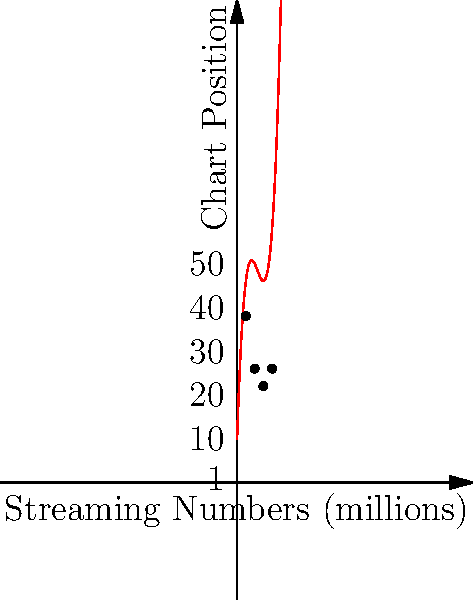As a music critic analyzing Taylor Swift's album performance, you've plotted the relationship between streaming numbers and chart positions for her recent albums using polynomial regression. The graph shows the trend line and actual data points. Based on the polynomial function $f(x) = 0.5x^3 - 7x^2 + 30x + 10$, where $x$ represents streaming numbers in millions and $f(x)$ represents chart position, at approximately how many million streams does the album reach its peak (lowest) chart position? To find the streaming number where the album reaches its peak (lowest) chart position, we need to follow these steps:

1) The peak (lowest) chart position occurs at the minimum point of the function.

2) To find the minimum point, we need to find where the derivative of the function equals zero:
   $f'(x) = 1.5x^2 - 14x + 30$

3) Set $f'(x) = 0$:
   $1.5x^2 - 14x + 30 = 0$

4) This is a quadratic equation. We can solve it using the quadratic formula:
   $x = \frac{-b \pm \sqrt{b^2 - 4ac}}{2a}$

   Where $a = 1.5$, $b = -14$, and $c = 30$

5) Plugging in these values:
   $x = \frac{14 \pm \sqrt{196 - 180}}{3} = \frac{14 \pm 4}{3}$

6) This gives us two solutions:
   $x_1 = \frac{14 + 4}{3} = 6$ and $x_2 = \frac{14 - 4}{3} = \frac{10}{3}$

7) The second solution, $\frac{10}{3}$, is outside our domain (the graph only goes up to 10 million streams).

Therefore, the album reaches its peak position at approximately 6 million streams.
Answer: 6 million streams 